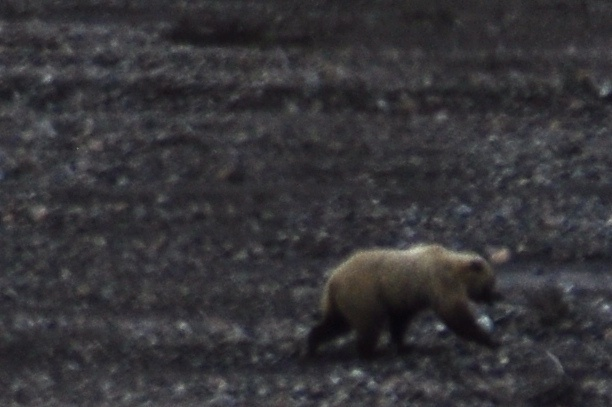Describe the objects in this image and their specific colors. I can see a bear in black and gray tones in this image. 